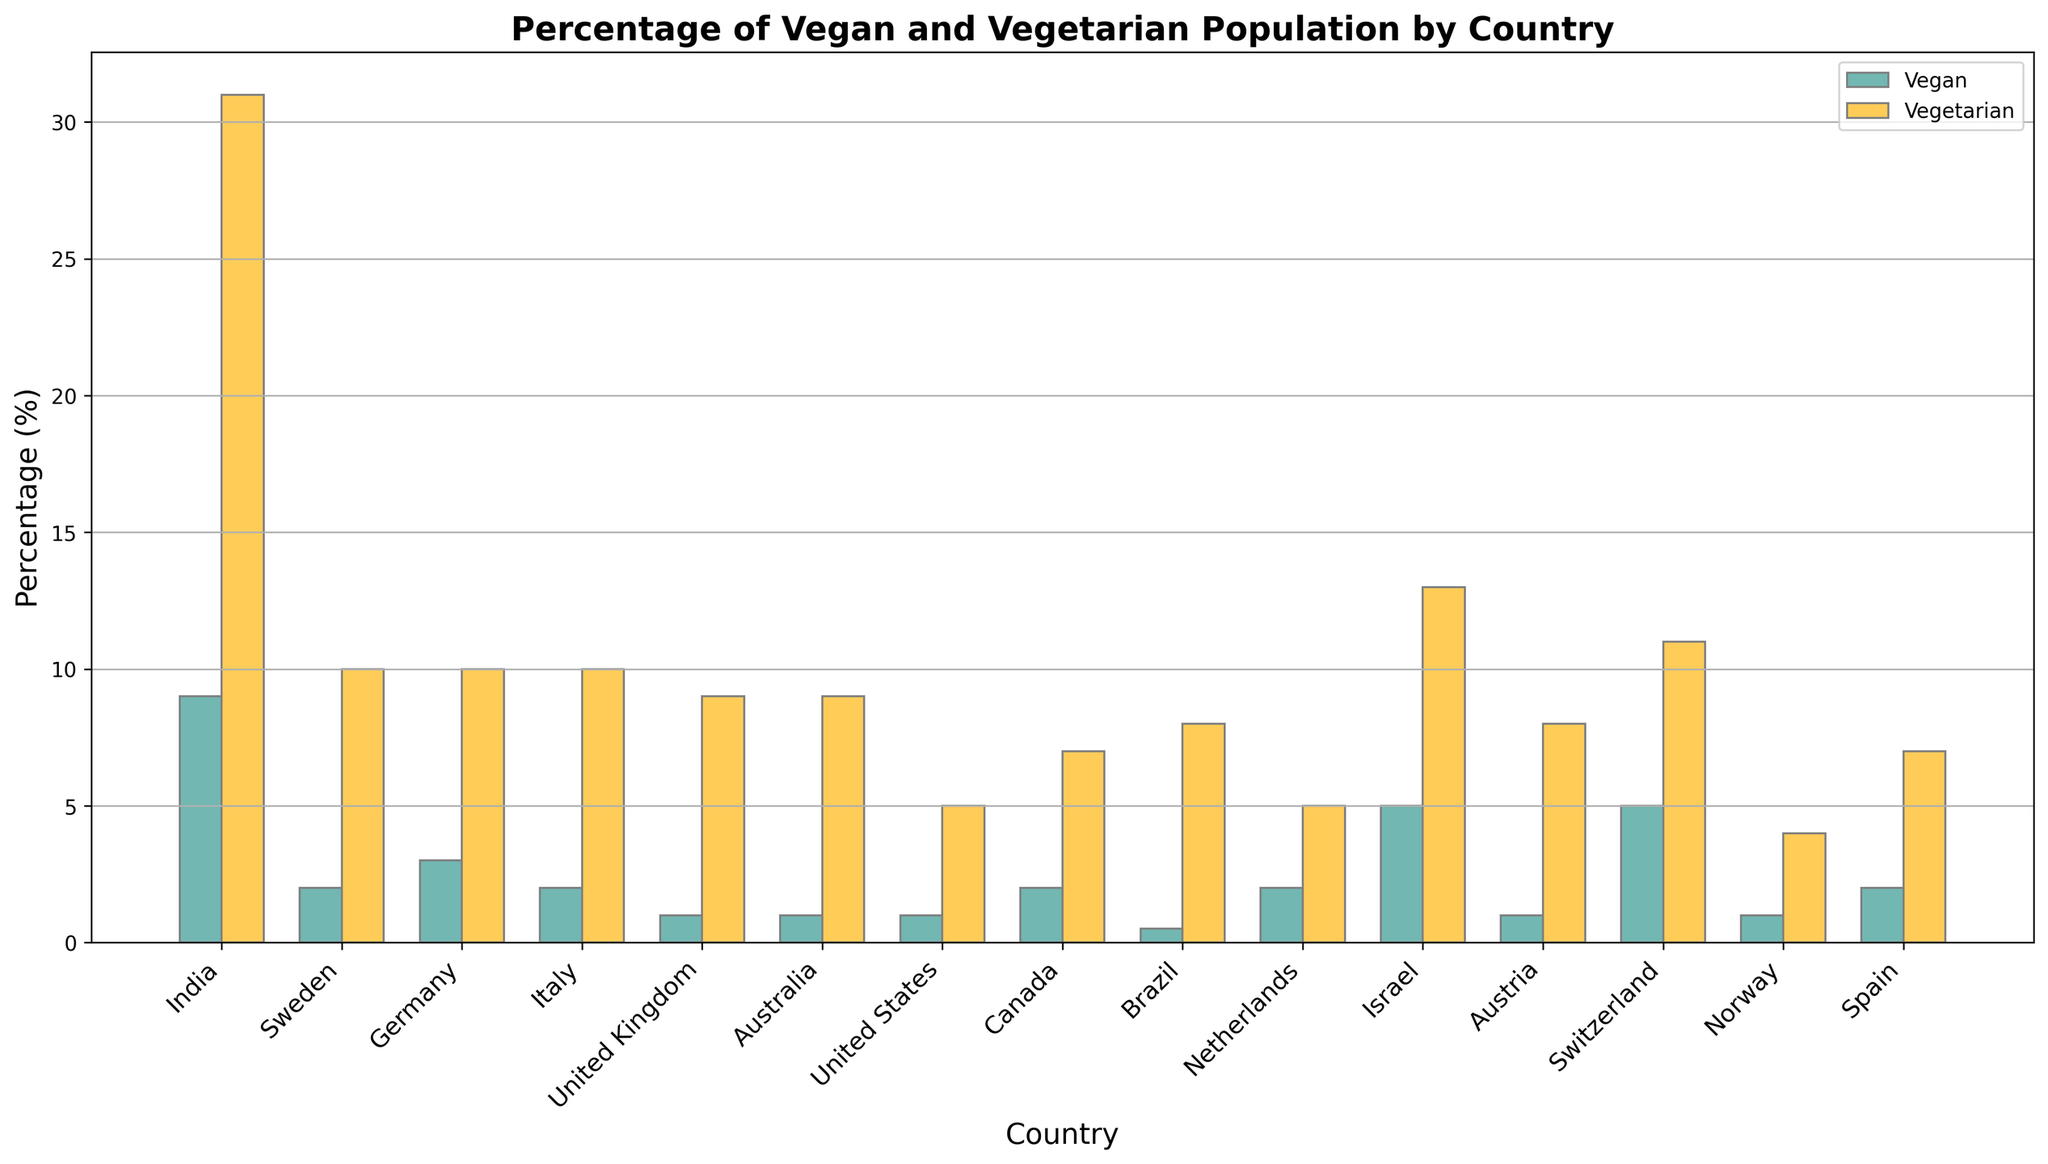Which country has the highest percentage of vegetarian population? By inspecting the height of the bars representing vegetarian population, we can see that India has the tallest bar.
Answer: India What's the average percentage of vegan population in Sweden, Germany, and Italy? First, sum the percentages: 2 (Sweden) + 3 (Germany) + 2 (Italy) = 7. Then, divide by the number of countries (3): 7 / 3 = 2.33.
Answer: 2.33 In which country is there the smallest difference between the vegan and vegetarian populations? By examining the bars for each country and calculating the differences: India (22), Sweden (8), Germany (7), Italy (8), United Kingdom (8), Australia (8), United States (4), Canada (5), Brazil (7.5), Netherlands (3), Israel (8), Austria (7), Switzerland (6), Norway (3), and Spain (5), we find that the Netherlands and Norway have the smallest difference of 3.
Answer: Netherlands, Norway Which country has the second highest vegan population percentage? By visually comparing the heights of the vegan bars, the highest is India. The second highest is Israel and Switzerland, each with a vegan population percentage of 5%.
Answer: Israel, Switzerland How many countries have a vegetarian population percentage greater than 10%? By counting the bars for vegetarian population greater than 10%, we find: India, Israel, and Switzerland.
Answer: 3 What is the combined percentage of vegan and vegetarian population in Canada? By adding the percentages for vegan (2) and vegetarian (7) in Canada: 2 + 7 = 9.
Answer: 9 Which country has a higher percentage of vegans, Israel or Germany? By comparing the height of the vegan bars, Israel has 5% and Germany has 3%. Thus, Israel has a higher percentage.
Answer: Israel What is the total percentage of the vegetarian population in the United Kingdom, Germany, and Australia combined? Adding the vegetarian percentages for the three countries: United Kingdom (9), Germany (10), and Australia (9): 9 + 10 + 9 = 28.
Answer: 28 Which country has the lowest percentage of vegans? By comparing the heights of the vegan bars, Brazil has the lowest vegan population percentage of 0.5%.
Answer: Brazil If you sum the vegan populations in the United States and Brazil, what is the result? Sum the vegan percentages of the United States (1) and Brazil (0.5): 1 + 0.5 = 1.5.
Answer: 1.5 